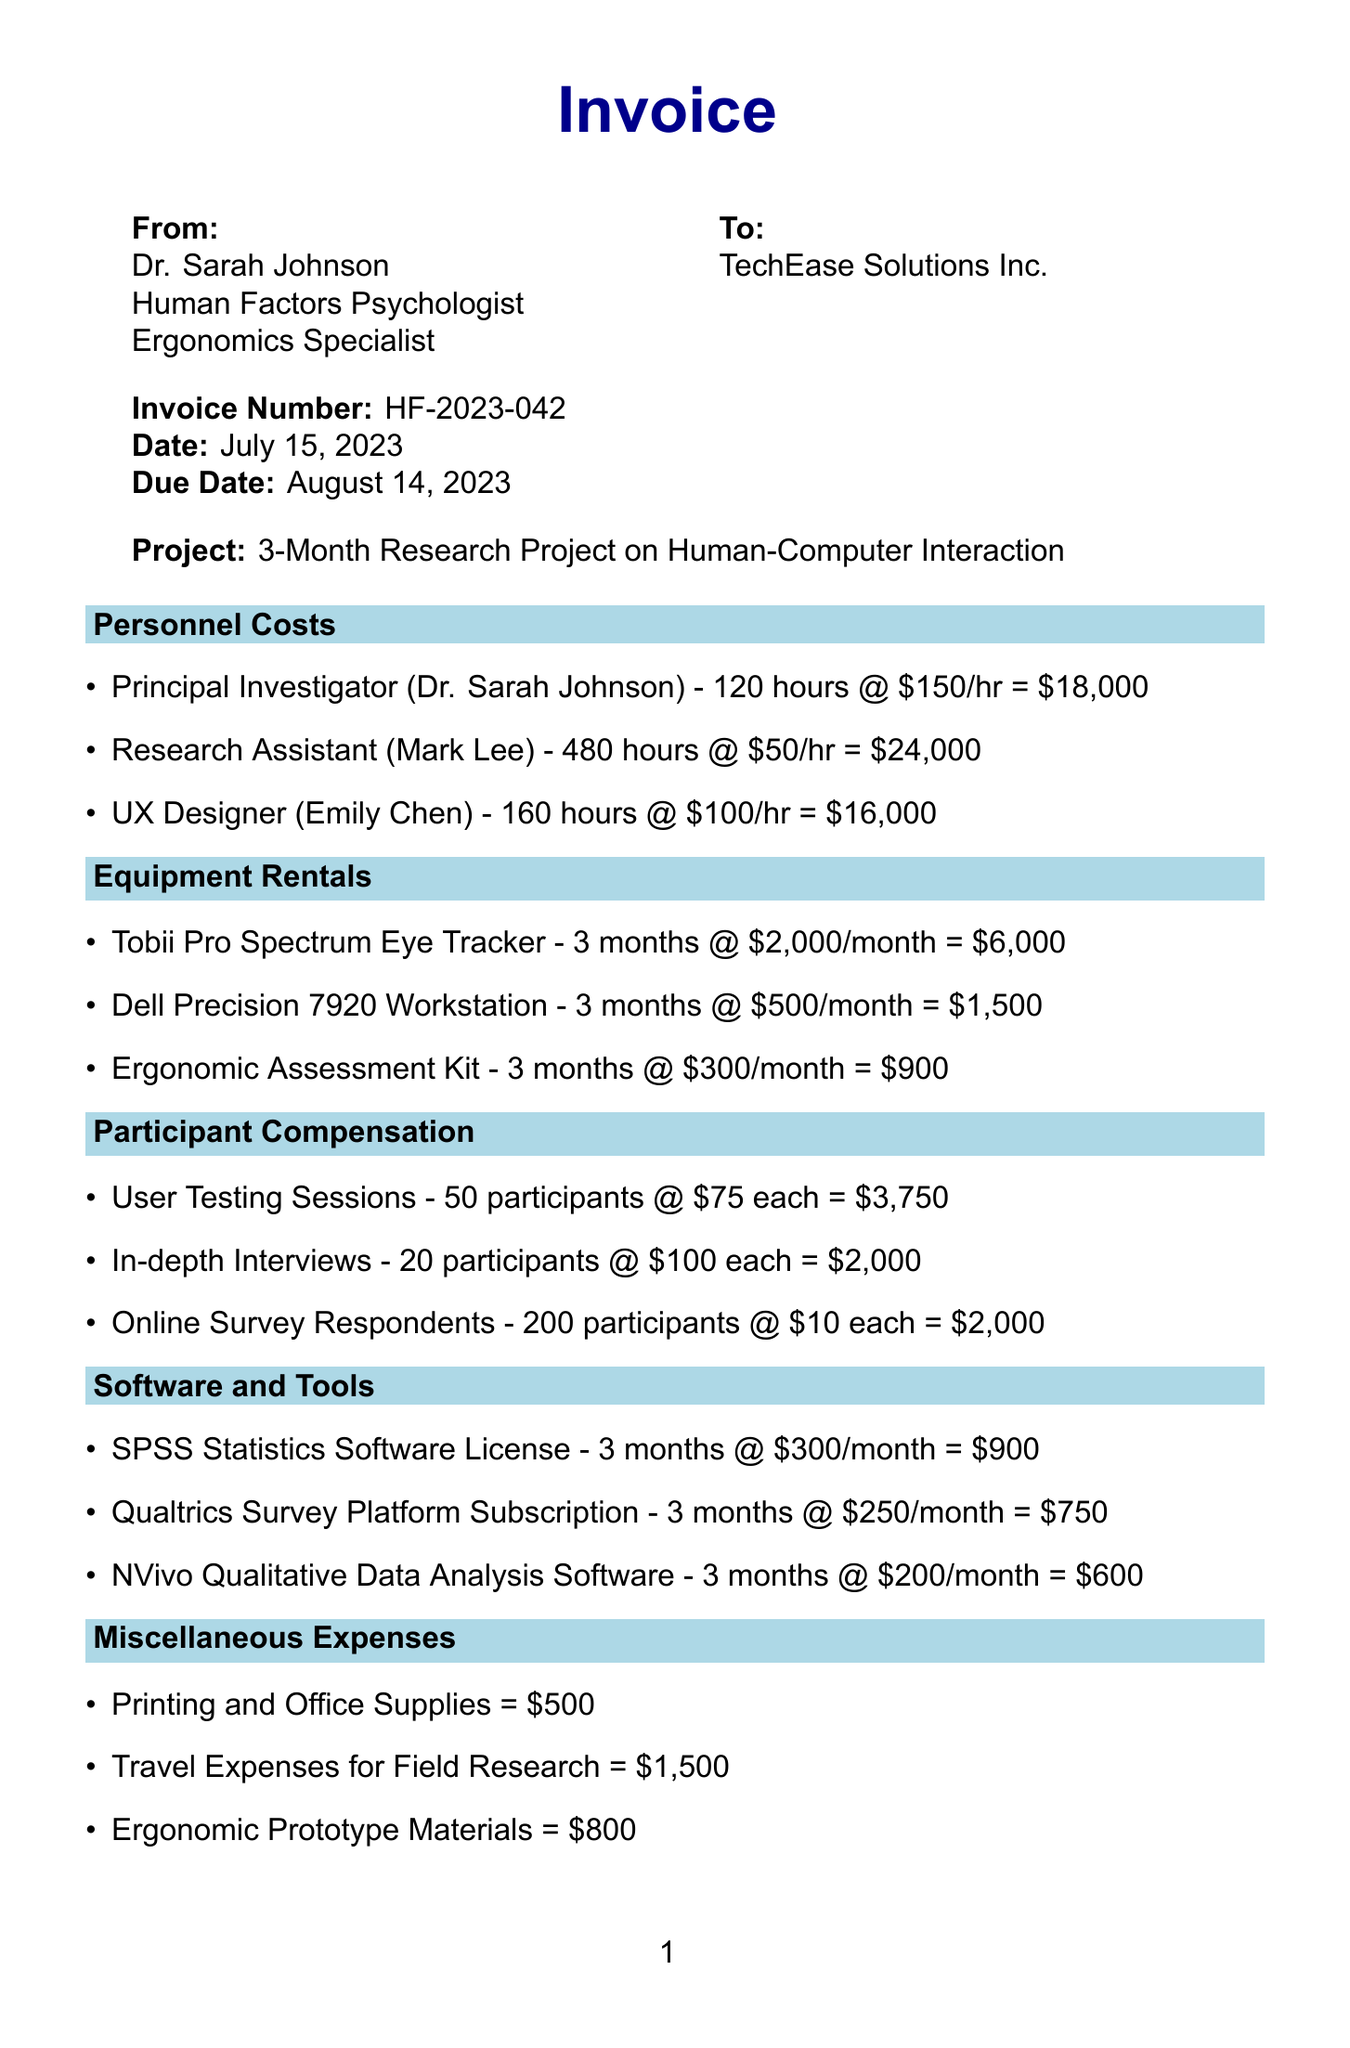What is the invoice number? The invoice number is stated clearly in the document, which is HF-2023-042.
Answer: HF-2023-042 Who is the Principal Investigator? The document lists Dr. Sarah Johnson as the Principal Investigator for the project.
Answer: Dr. Sarah Johnson What is the total due amount? The total amount due is summed at the bottom of the document, which is $85,536.
Answer: $85,536 How many hours did the Research Assistant work? The document specifies that the Research Assistant (Mark Lee) worked 480 hours.
Answer: 480 hours What is the rate for online survey respondents? The invoice mentions that the rate for online survey respondents is $10 each.
Answer: $10 What is the amount for travel expenses? The invoice lists the travel expenses for field research as $1,500.
Answer: $1,500 How many participants were compensated for user testing sessions? The invoice states that 50 participants were compensated for user testing sessions.
Answer: 50 participants What category does the SPSS software license fall under? The SPSS Statistics Software License is classified under the "Software and Tools" category.
Answer: Software and Tools What percentage is applied for tax in this invoice? The tax rate indicated in the document is 8%.
Answer: 8% 